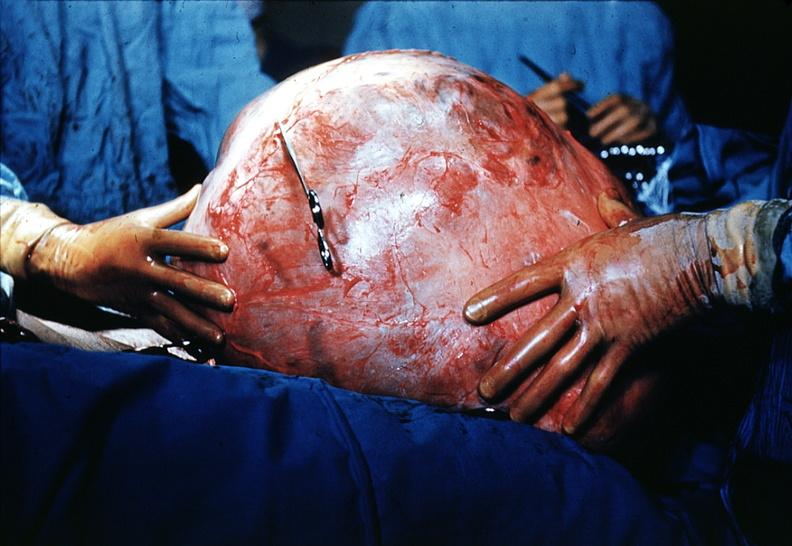s gangrene present?
Answer the question using a single word or phrase. No 